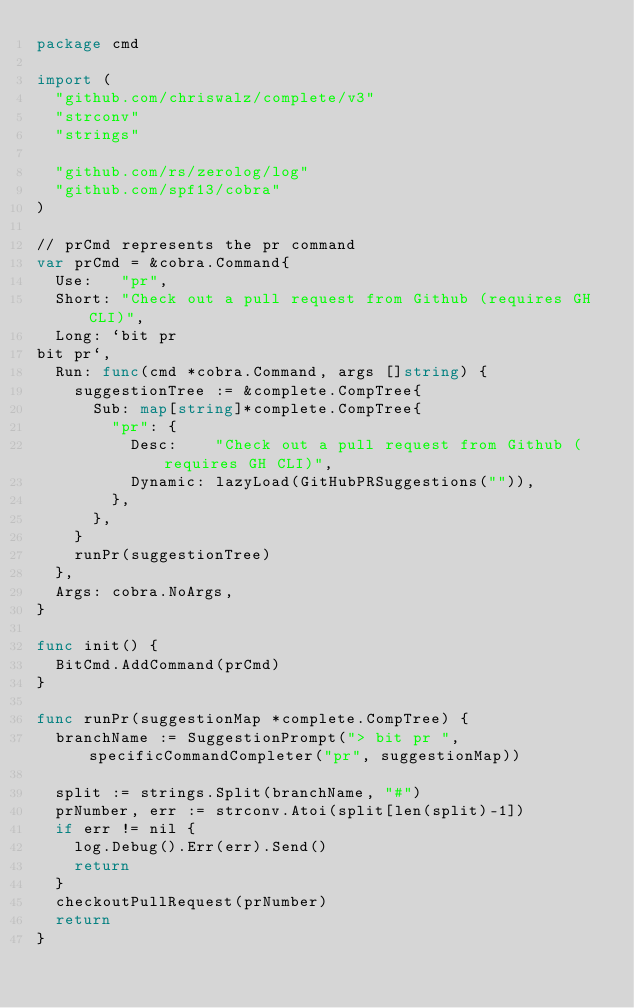<code> <loc_0><loc_0><loc_500><loc_500><_Go_>package cmd

import (
	"github.com/chriswalz/complete/v3"
	"strconv"
	"strings"

	"github.com/rs/zerolog/log"
	"github.com/spf13/cobra"
)

// prCmd represents the pr command
var prCmd = &cobra.Command{
	Use:   "pr",
	Short: "Check out a pull request from Github (requires GH CLI)",
	Long: `bit pr
bit pr`,
	Run: func(cmd *cobra.Command, args []string) {
		suggestionTree := &complete.CompTree{
			Sub: map[string]*complete.CompTree{
				"pr": {
					Desc:    "Check out a pull request from Github (requires GH CLI)",
					Dynamic: lazyLoad(GitHubPRSuggestions("")),
				},
			},
		}
		runPr(suggestionTree)
	},
	Args: cobra.NoArgs,
}

func init() {
	BitCmd.AddCommand(prCmd)
}

func runPr(suggestionMap *complete.CompTree) {
	branchName := SuggestionPrompt("> bit pr ", specificCommandCompleter("pr", suggestionMap))

	split := strings.Split(branchName, "#")
	prNumber, err := strconv.Atoi(split[len(split)-1])
	if err != nil {
		log.Debug().Err(err).Send()
		return
	}
	checkoutPullRequest(prNumber)
	return
}
</code> 